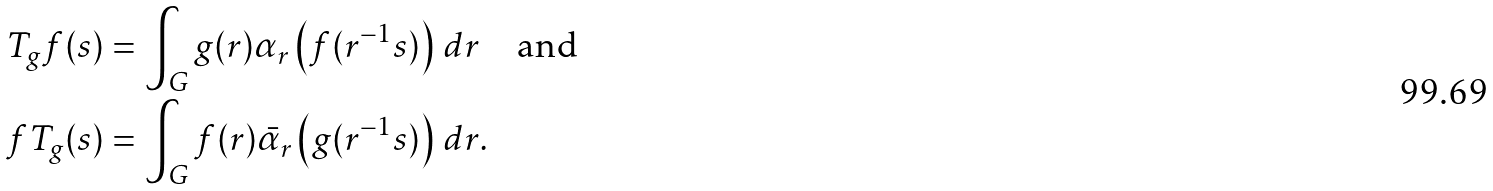Convert formula to latex. <formula><loc_0><loc_0><loc_500><loc_500>T _ { g } f ( s ) & = \int _ { G } g ( r ) \alpha _ { r } \left ( f ( r ^ { - 1 } s ) \right ) \, d r \quad \text {and} \\ f T _ { g } ( s ) & = \int _ { G } f ( r ) \bar { \alpha } _ { r } \left ( g ( r ^ { - 1 } s ) \right ) \, d r .</formula> 